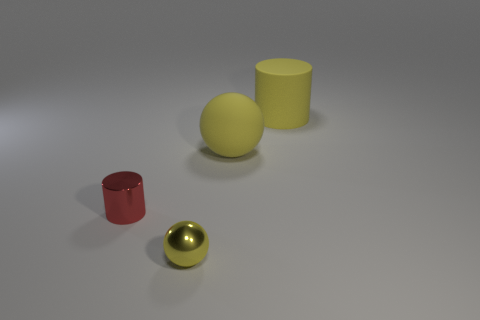Add 2 brown matte blocks. How many objects exist? 6 Subtract 0 gray balls. How many objects are left? 4 Subtract all large cyan rubber cylinders. Subtract all balls. How many objects are left? 2 Add 2 big yellow matte spheres. How many big yellow matte spheres are left? 3 Add 3 cylinders. How many cylinders exist? 5 